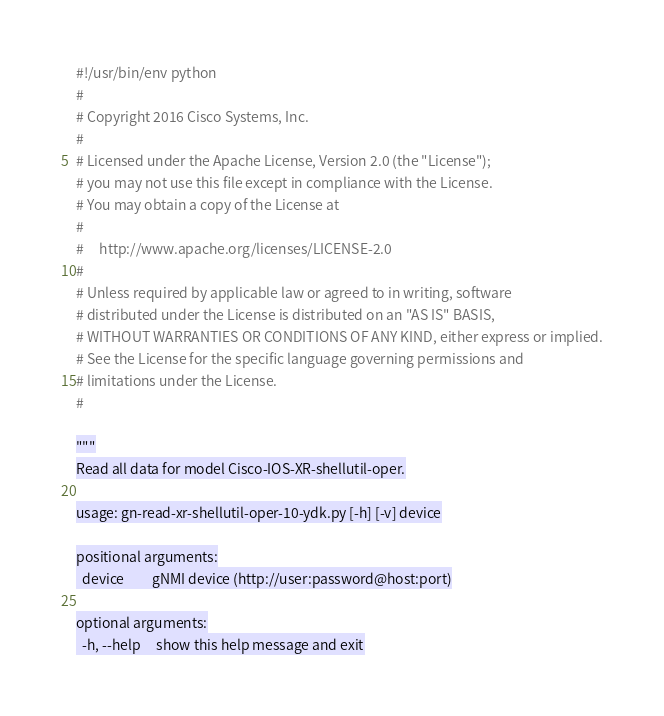Convert code to text. <code><loc_0><loc_0><loc_500><loc_500><_Python_>#!/usr/bin/env python
#
# Copyright 2016 Cisco Systems, Inc.
#
# Licensed under the Apache License, Version 2.0 (the "License");
# you may not use this file except in compliance with the License.
# You may obtain a copy of the License at
#
#     http://www.apache.org/licenses/LICENSE-2.0
#
# Unless required by applicable law or agreed to in writing, software
# distributed under the License is distributed on an "AS IS" BASIS,
# WITHOUT WARRANTIES OR CONDITIONS OF ANY KIND, either express or implied.
# See the License for the specific language governing permissions and
# limitations under the License.
#

"""
Read all data for model Cisco-IOS-XR-shellutil-oper.

usage: gn-read-xr-shellutil-oper-10-ydk.py [-h] [-v] device

positional arguments:
  device         gNMI device (http://user:password@host:port)

optional arguments:
  -h, --help     show this help message and exit</code> 